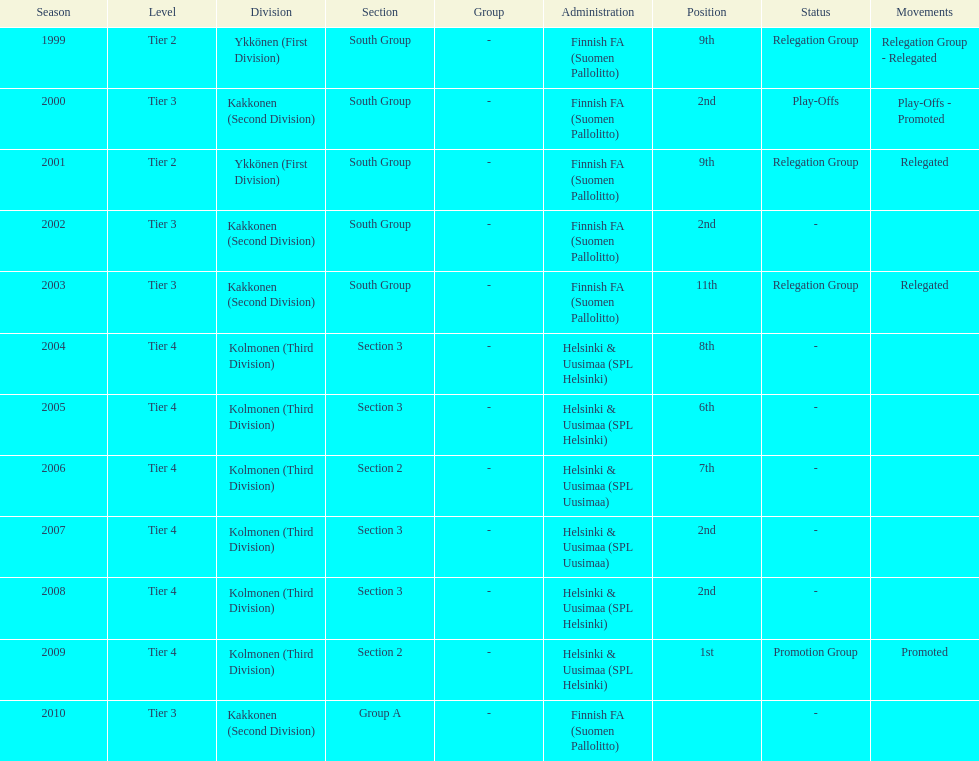What position did this team get after getting 9th place in 1999? 2nd. 